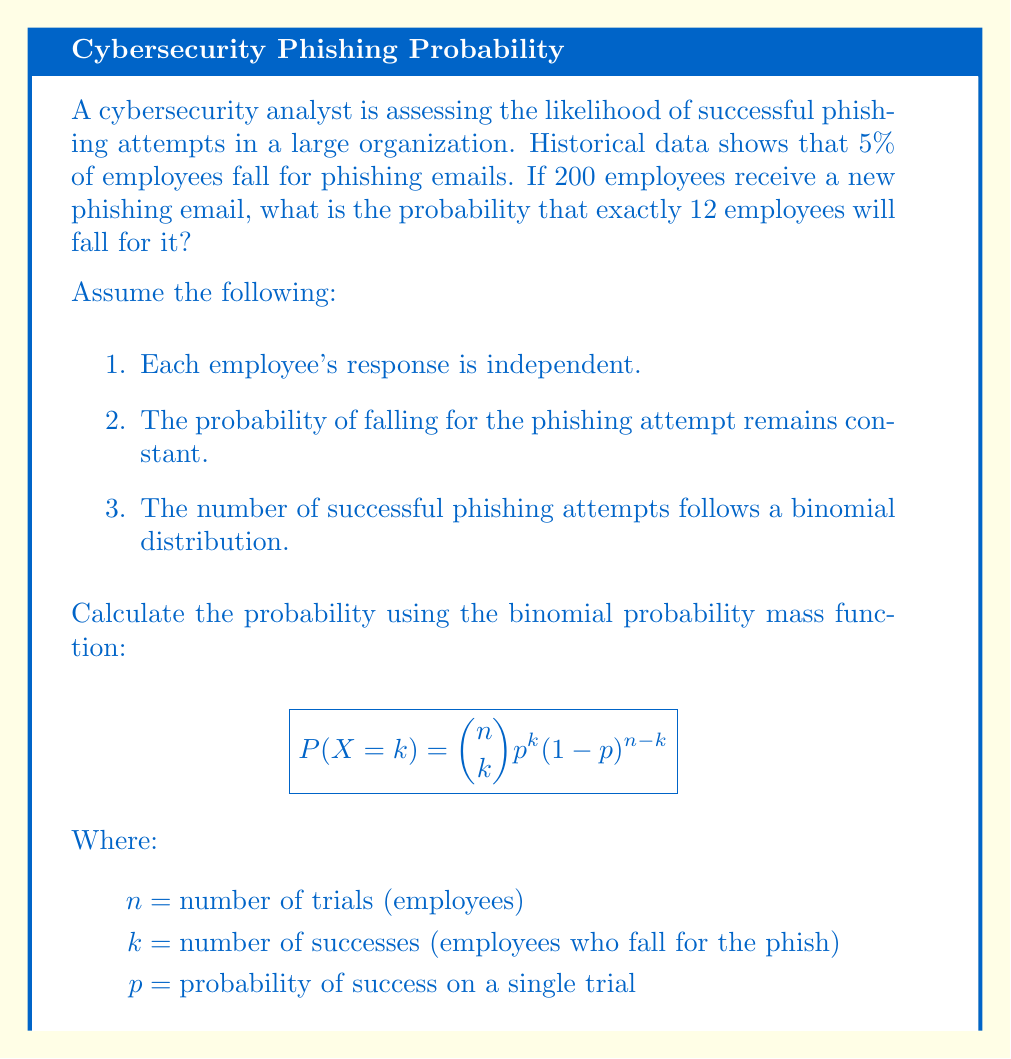Can you answer this question? To solve this problem, we'll use the binomial probability mass function:

$$P(X = k) = \binom{n}{k} p^k (1-p)^{n-k}$$

Given:
$n = 200$ (total number of employees)
$k = 12$ (number of employees who fall for the phish)
$p = 0.05$ (probability of falling for a phishing attempt)

Step 1: Calculate the binomial coefficient $\binom{n}{k}$
$$\binom{200}{12} = \frac{200!}{12!(200-12)!} = \frac{200!}{12!188!} = 1,654,110,452,$$

Step 2: Calculate $p^k$
$$0.05^{12} = 2.44140625 \times 10^{-16}$$

Step 3: Calculate $(1-p)^{n-k}$
$$(1-0.05)^{200-12} = 0.95^{188} = 0.000517306$$

Step 4: Multiply the results from steps 1, 2, and 3
$$1,654,110,452 \times 2.44140625 \times 10^{-16} \times 0.000517306 = 0.0208246$$

Therefore, the probability of exactly 12 employees falling for the phishing attempt is approximately 0.0208246 or 2.08%.
Answer: 0.0208 or 2.08% 